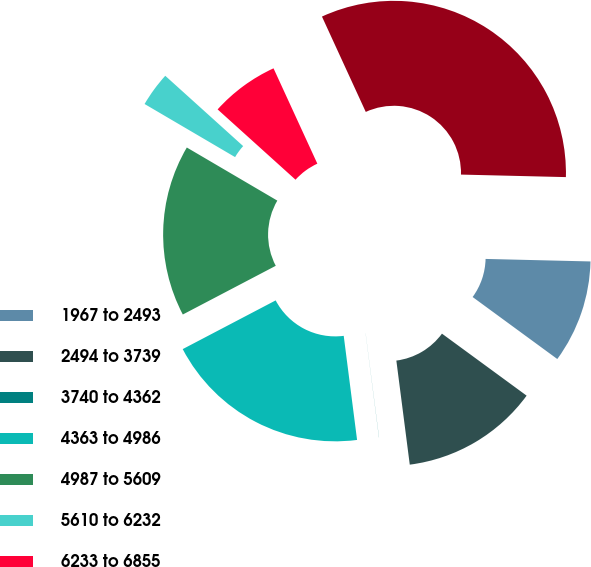Convert chart to OTSL. <chart><loc_0><loc_0><loc_500><loc_500><pie_chart><fcel>1967 to 2493<fcel>2494 to 3739<fcel>3740 to 4362<fcel>4363 to 4986<fcel>4987 to 5609<fcel>5610 to 6232<fcel>6233 to 6855<fcel>1967 to 6855<nl><fcel>9.68%<fcel>12.9%<fcel>0.01%<fcel>19.35%<fcel>16.13%<fcel>3.24%<fcel>6.46%<fcel>32.24%<nl></chart> 